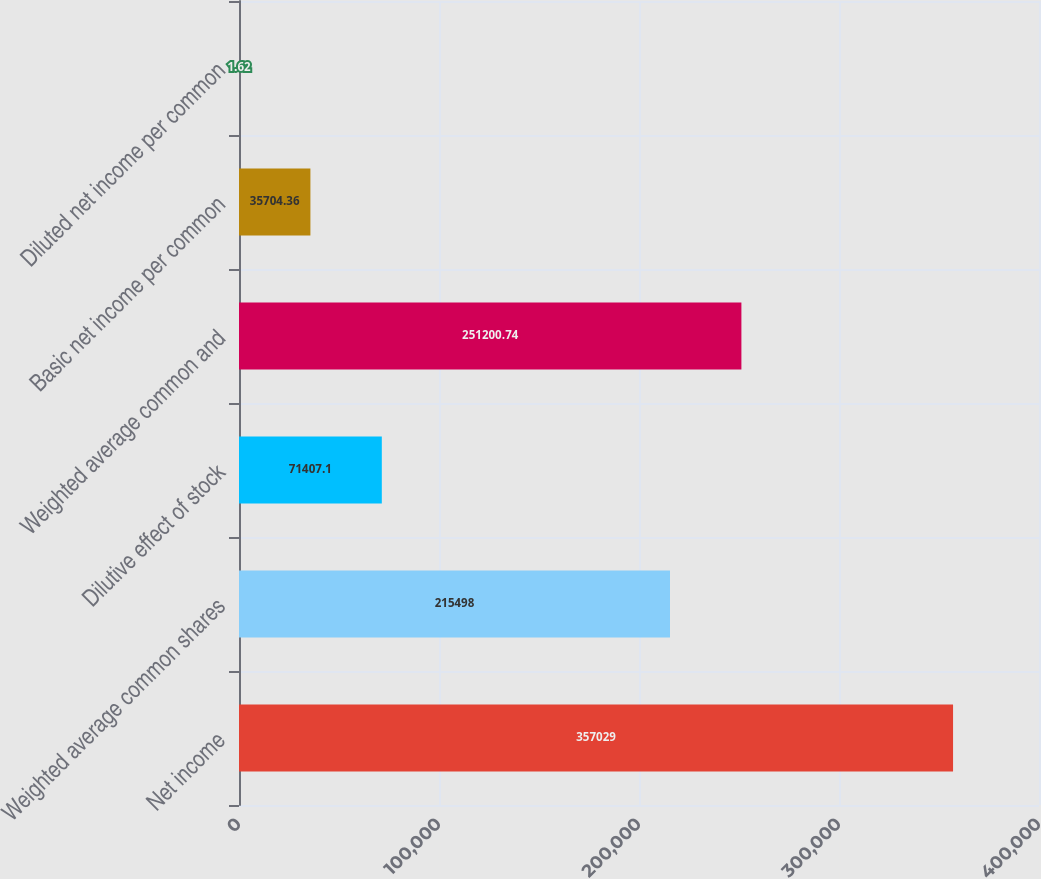Convert chart to OTSL. <chart><loc_0><loc_0><loc_500><loc_500><bar_chart><fcel>Net income<fcel>Weighted average common shares<fcel>Dilutive effect of stock<fcel>Weighted average common and<fcel>Basic net income per common<fcel>Diluted net income per common<nl><fcel>357029<fcel>215498<fcel>71407.1<fcel>251201<fcel>35704.4<fcel>1.62<nl></chart> 